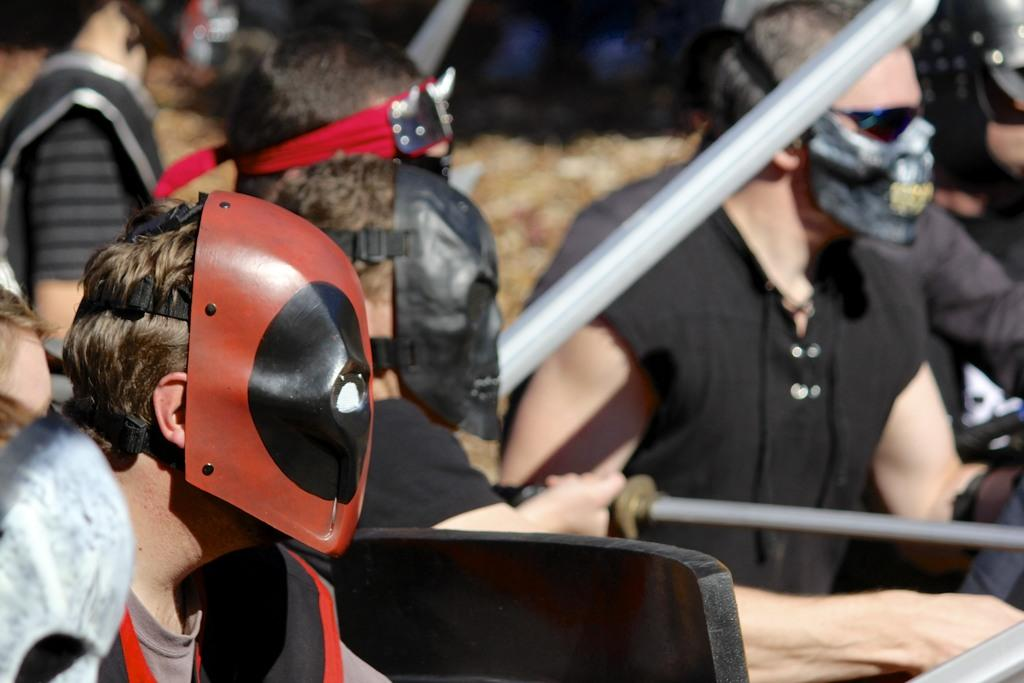Who or what can be seen in the image? There are people in the image. What are the people wearing on their faces? The people are wearing masks on their faces. What are the people holding in their hands? The people are holding objects in their hands. What type of organization is the group of girls in the image a part of? There is no mention of girls in the image, and no organization is indicated. 